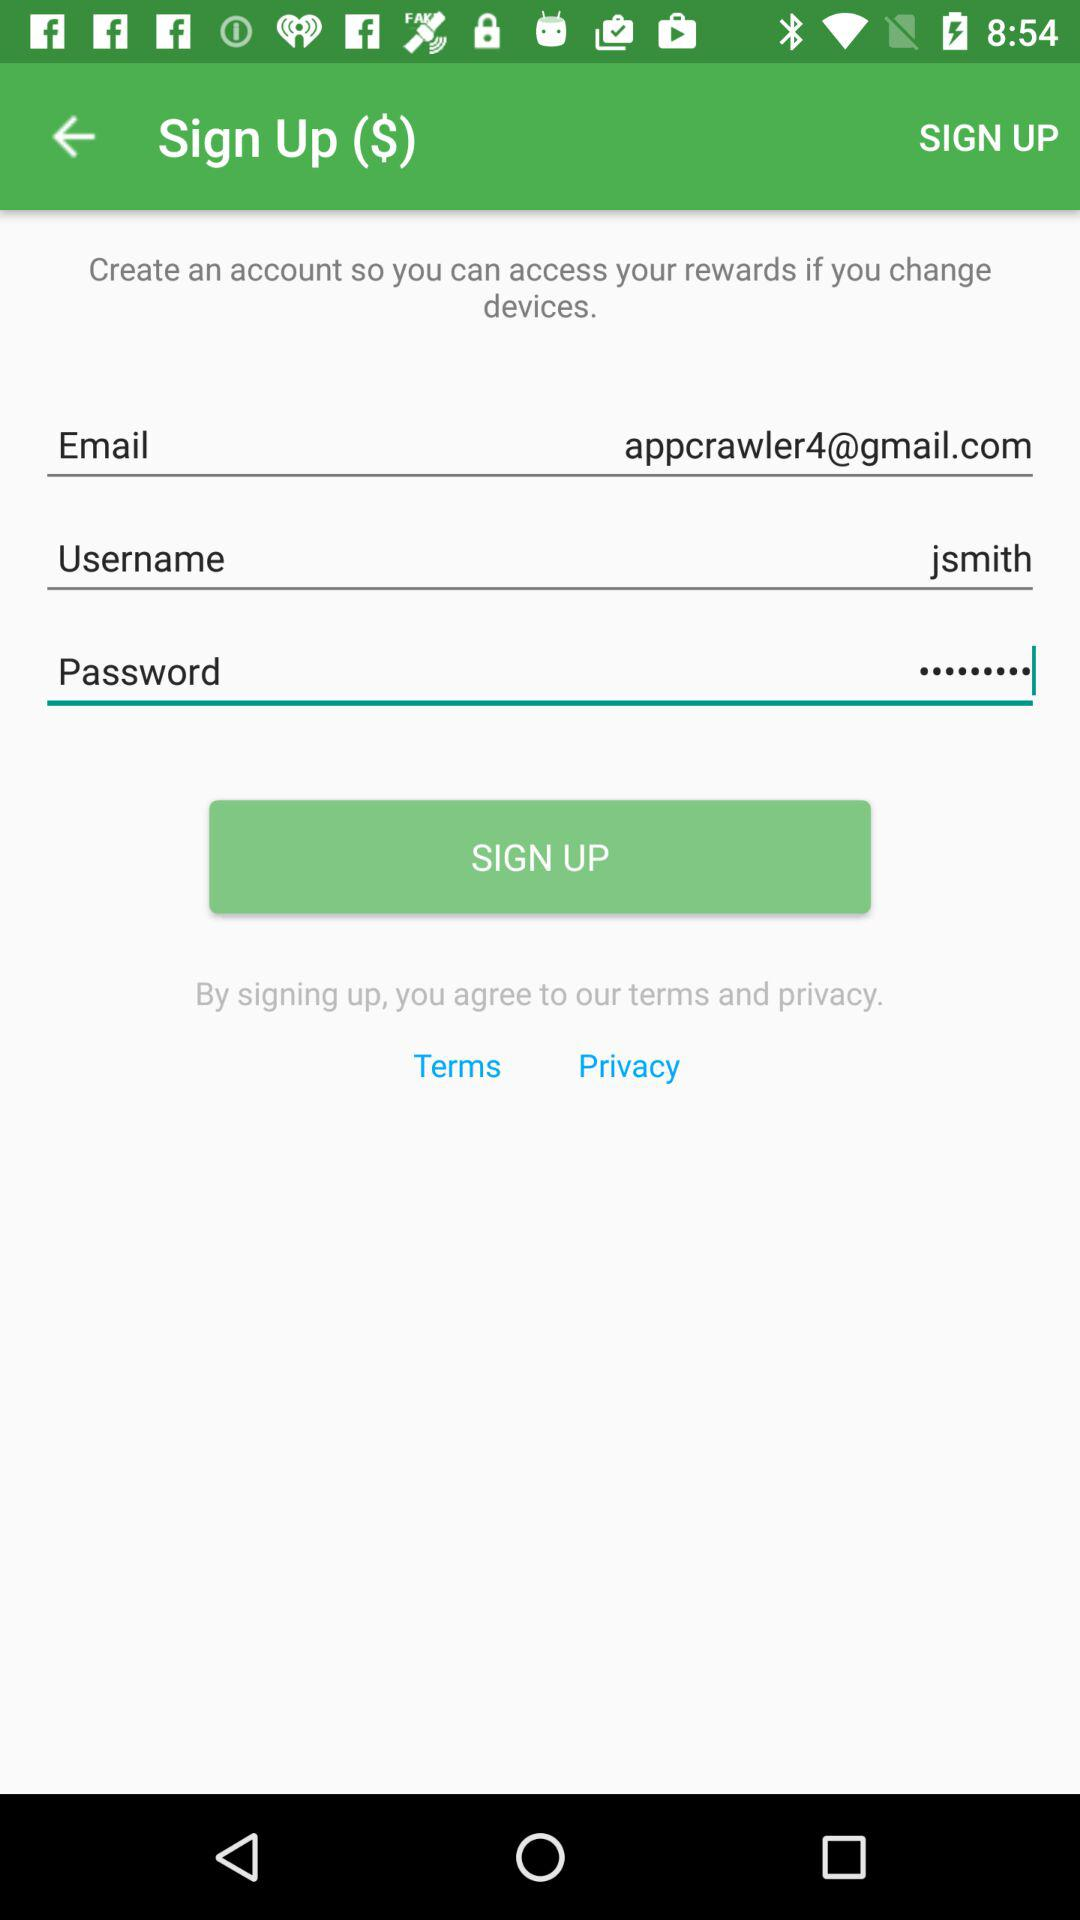What is the email address? The email address is appcrawler4@gmail.com. 